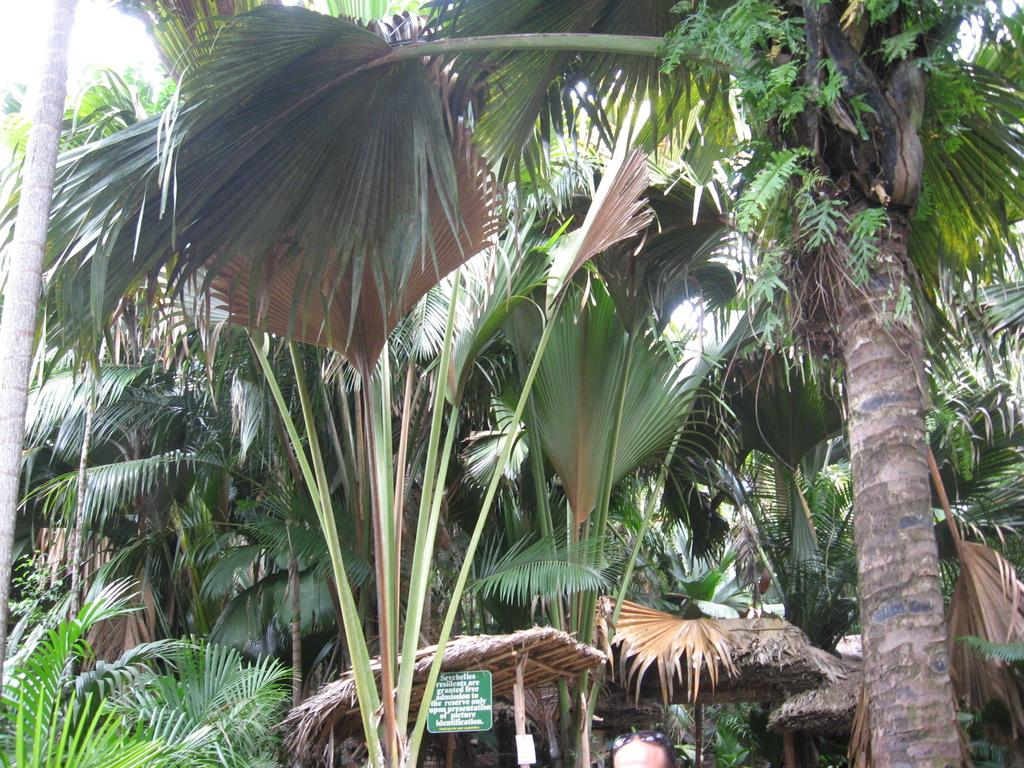What type of natural elements can be seen in the image? There are trees in the image. What structures are located at the bottom of the image? There are shelters at the bottom of the image. What object is present at the bottom of the image, near the shelters? There is a board at the bottom of the image. Can you describe the person visible in the image? The head of a person with goggles is visible in the image. What type of underwear is the giant wearing in the image? There are no giants or underwear present in the image. How deep is the hole in the image? There is no hole present in the image. 